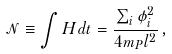Convert formula to latex. <formula><loc_0><loc_0><loc_500><loc_500>\mathcal { N } \equiv \int H d t = \frac { \sum _ { i } \phi _ { i } ^ { 2 } } { 4 m _ { P } l ^ { 2 } } \, ,</formula> 